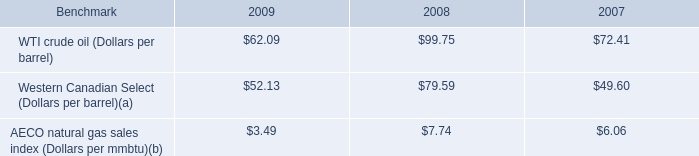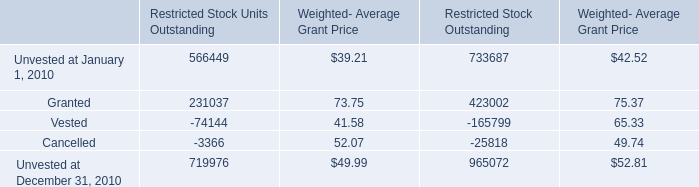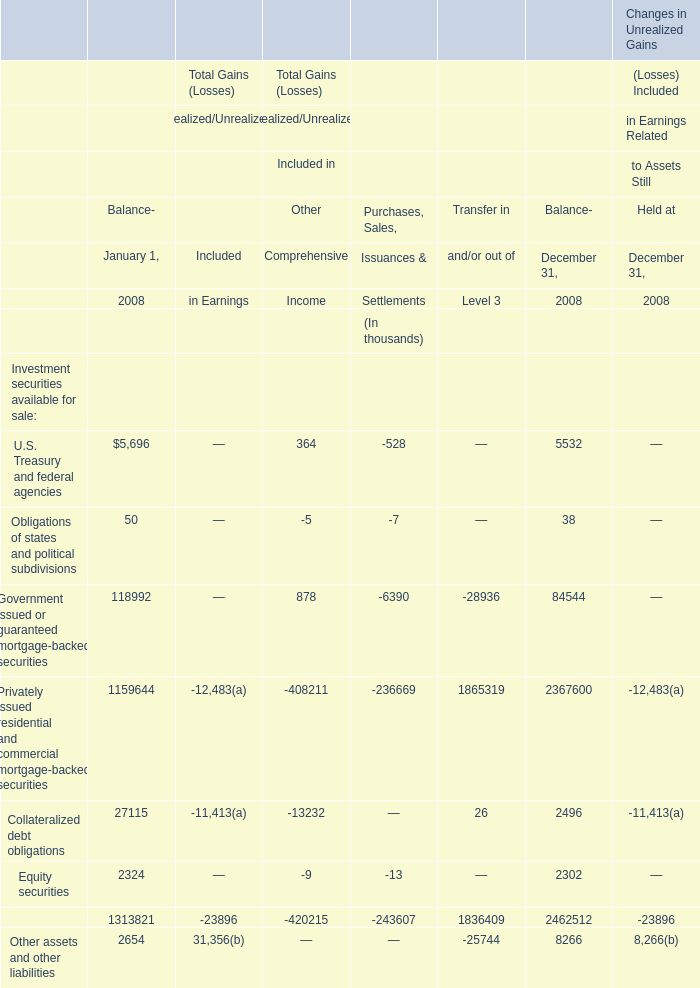by what percentage did the average price of the wti crude oil benchmark decrease from 2008 to 2009? 
Computations: ((62.09 - 99.75) / 99.75)
Answer: -0.37754. 